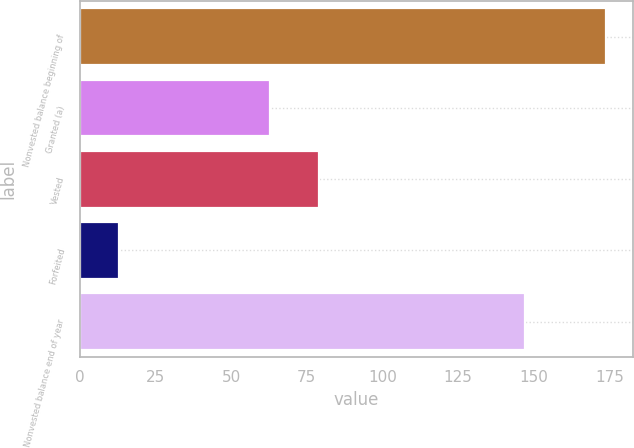Convert chart. <chart><loc_0><loc_0><loc_500><loc_500><bar_chart><fcel>Nonvested balance beginning of<fcel>Granted (a)<fcel>Vested<fcel>Forfeited<fcel>Nonvested balance end of year<nl><fcel>174<fcel>63<fcel>79.1<fcel>13<fcel>147<nl></chart> 